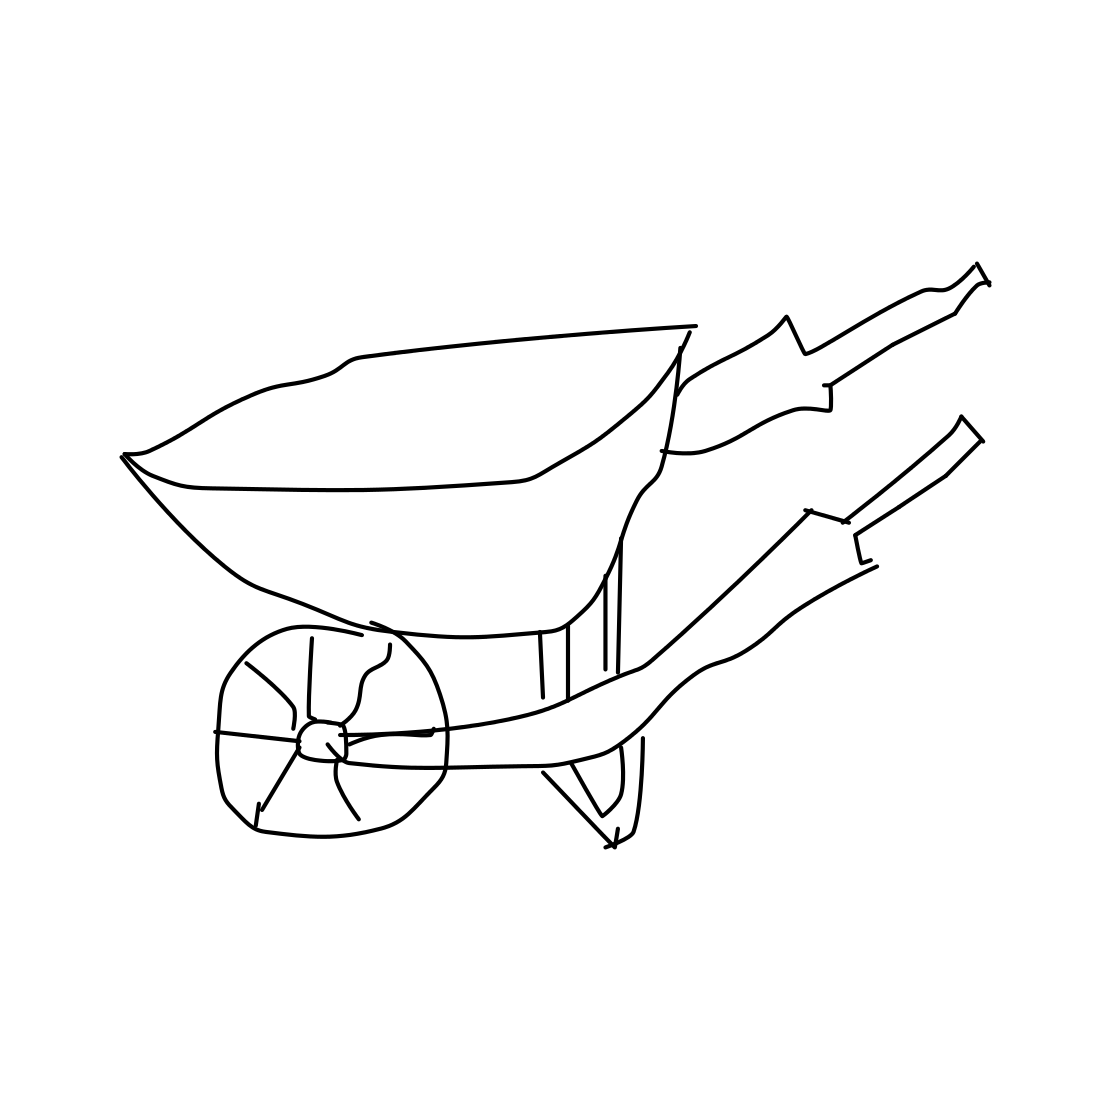Can you tell me what the common uses for a wheelbarrow are? Certainly! A wheelbarrow is commonly used for transporting materials like soil, sand, gravel, or plants over short distances. It's an essential tool in gardening, landscaping, and construction work because it helps to distribute the weight of a load between the wheel and the operator, making it easier to maneuver.  What's the significance of the single wheel design? The single wheel design of a wheelbarrow allows for easier steering and tight maneuvering, which is especially useful in narrow spaces like garden paths or construction sites. It also enables the user to balance the load over the wheel, minimizing the effort required to lift and move heavy materials. 